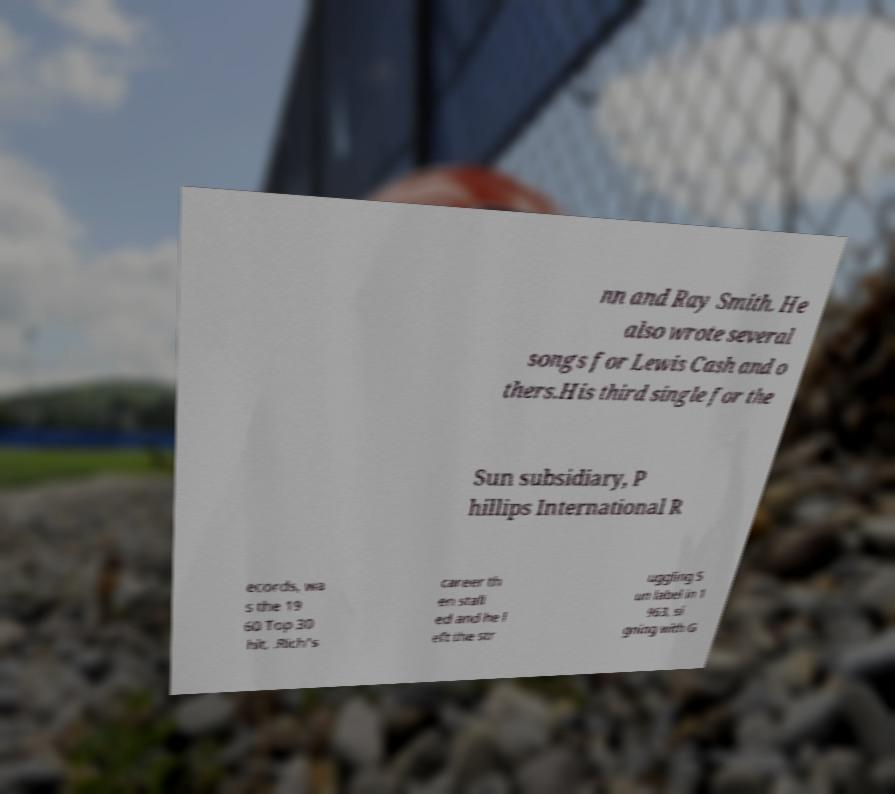Can you read and provide the text displayed in the image?This photo seems to have some interesting text. Can you extract and type it out for me? nn and Ray Smith. He also wrote several songs for Lewis Cash and o thers.His third single for the Sun subsidiary, P hillips International R ecords, wa s the 19 60 Top 30 hit, .Rich's career th en stall ed and he l eft the str uggling S un label in 1 963, si gning with G 